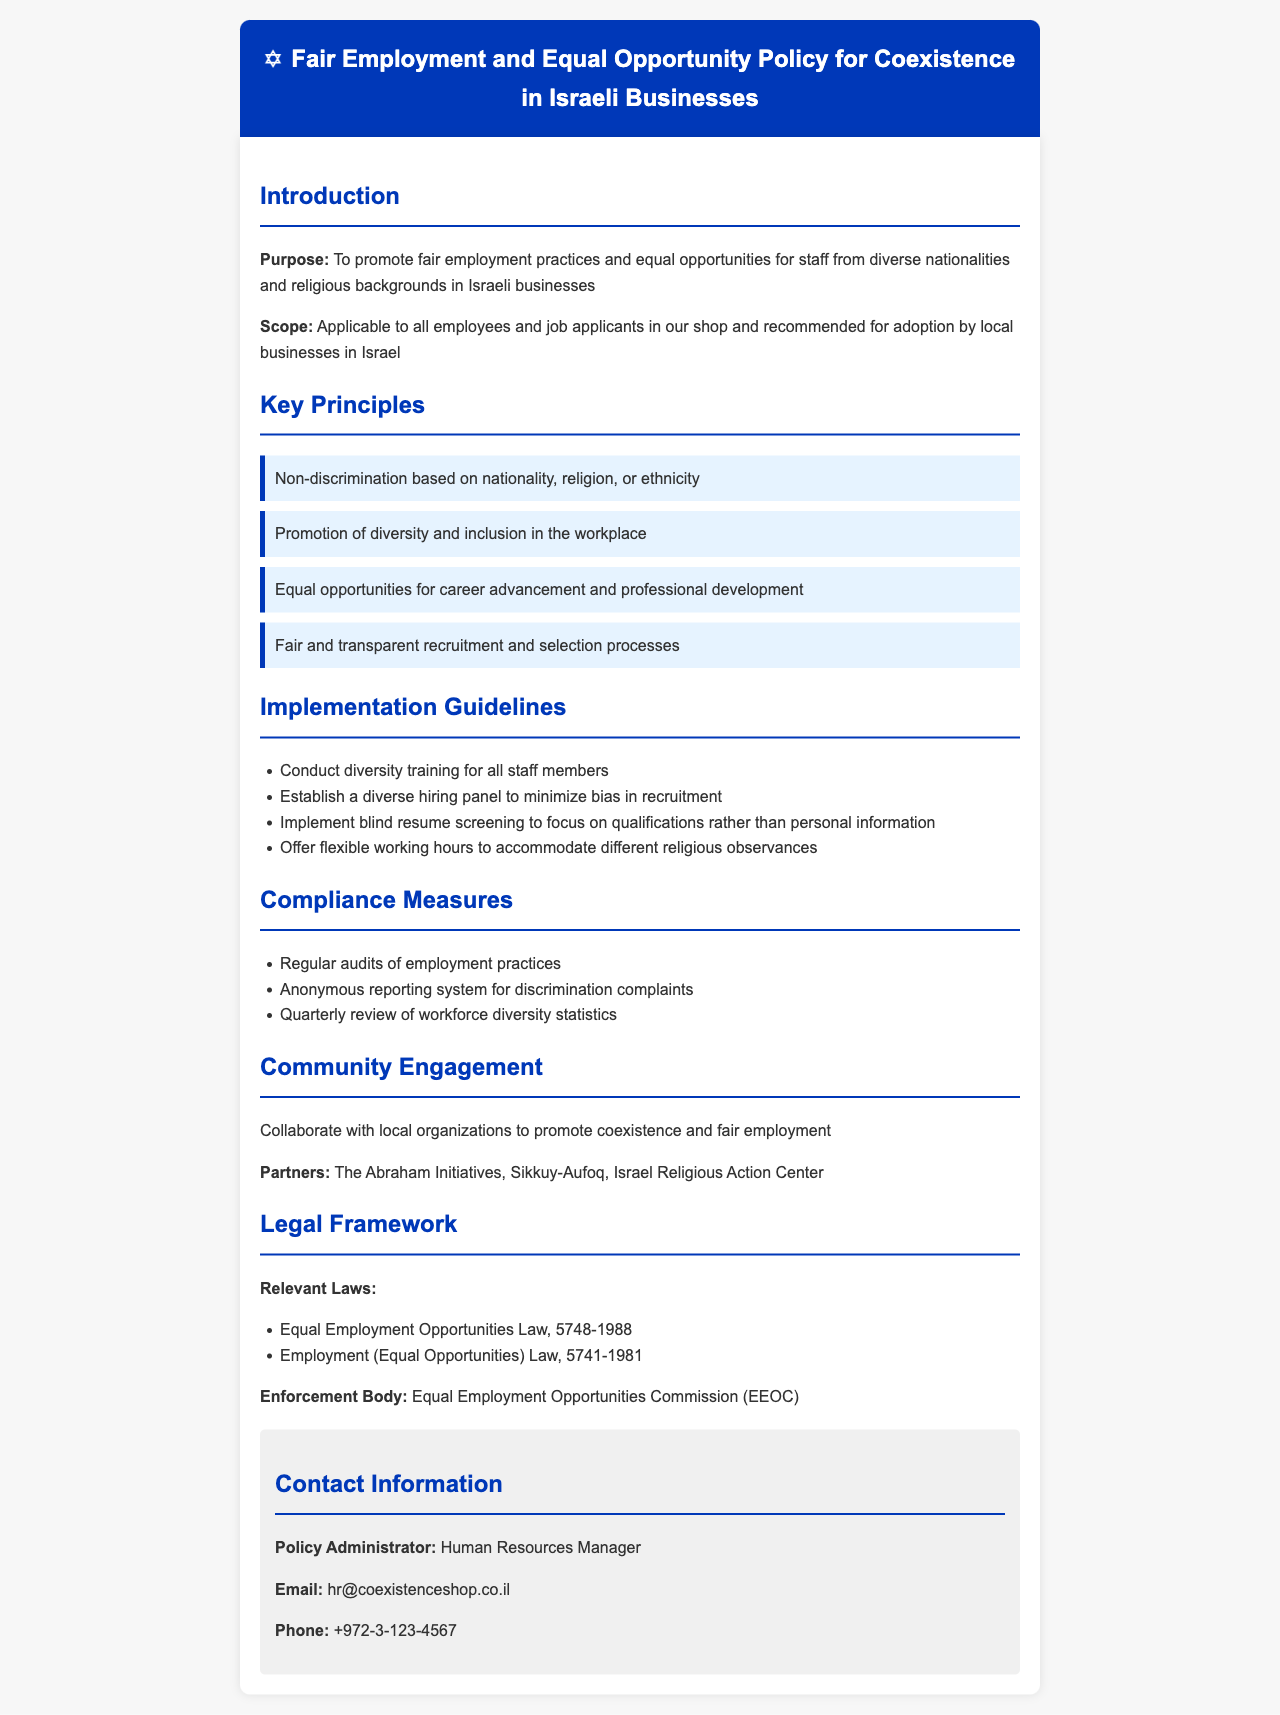What is the purpose of the policy? The purpose of the policy is to promote fair employment practices and equal opportunities for staff from diverse nationalities and religious backgrounds in Israeli businesses.
Answer: To promote fair employment practices and equal opportunities What are the relevant laws mentioned? The relevant laws listed in the document include Equal Employment Opportunities Law, 5748-1988 and Employment (Equal Opportunities) Law, 5741-1981.
Answer: Equal Employment Opportunities Law, 5748-1988; Employment (Equal Opportunities) Law, 5741-1981 Who is the policy administrator? The document states that the Human Resources Manager is the policy administrator.
Answer: Human Resources Manager What is one key principle of the policy? The document outlines several key principles, one of which is non-discrimination based on nationality, religion, or ethnicity.
Answer: Non-discrimination based on nationality, religion, or ethnicity How often are workforce diversity statistics reviewed? According to the compliance measures, workforce diversity statistics are reviewed quarterly.
Answer: Quarterly What type of training is suggested for staff? The policy recommends conducting diversity training for all staff members.
Answer: Diversity training What organization is a partner for community engagement? The document lists The Abraham Initiatives as one of the partners for promoting coexistence and fair employment.
Answer: The Abraham Initiatives What should be conducted to minimize bias in recruitment? The implementation guidelines suggest establishing a diverse hiring panel to minimize bias during recruitment.
Answer: Establish a diverse hiring panel 